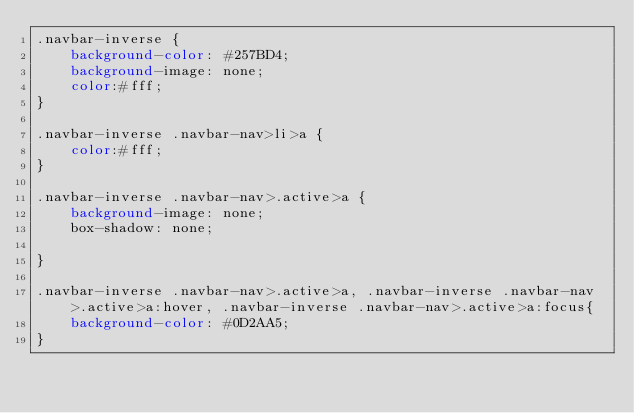<code> <loc_0><loc_0><loc_500><loc_500><_CSS_>.navbar-inverse {
    background-color: #257BD4;
    background-image: none;
    color:#fff;
}

.navbar-inverse .navbar-nav>li>a {
    color:#fff;
}

.navbar-inverse .navbar-nav>.active>a {
    background-image: none;
    box-shadow: none;
    
}

.navbar-inverse .navbar-nav>.active>a, .navbar-inverse .navbar-nav>.active>a:hover, .navbar-inverse .navbar-nav>.active>a:focus{
    background-color: #0D2AA5;
}</code> 